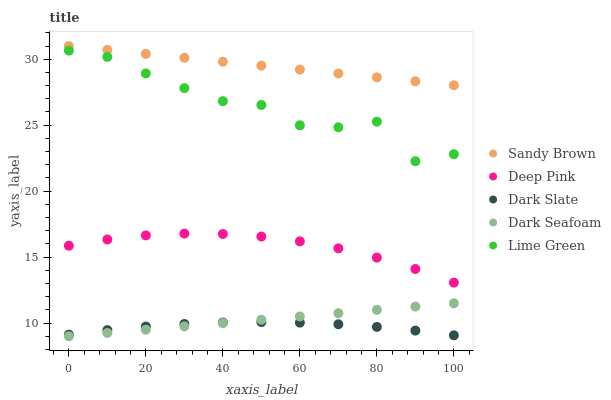Does Dark Slate have the minimum area under the curve?
Answer yes or no. Yes. Does Sandy Brown have the maximum area under the curve?
Answer yes or no. Yes. Does Dark Seafoam have the minimum area under the curve?
Answer yes or no. No. Does Dark Seafoam have the maximum area under the curve?
Answer yes or no. No. Is Sandy Brown the smoothest?
Answer yes or no. Yes. Is Lime Green the roughest?
Answer yes or no. Yes. Is Dark Seafoam the smoothest?
Answer yes or no. No. Is Dark Seafoam the roughest?
Answer yes or no. No. Does Dark Seafoam have the lowest value?
Answer yes or no. Yes. Does Deep Pink have the lowest value?
Answer yes or no. No. Does Sandy Brown have the highest value?
Answer yes or no. Yes. Does Dark Seafoam have the highest value?
Answer yes or no. No. Is Dark Seafoam less than Deep Pink?
Answer yes or no. Yes. Is Lime Green greater than Deep Pink?
Answer yes or no. Yes. Does Dark Slate intersect Dark Seafoam?
Answer yes or no. Yes. Is Dark Slate less than Dark Seafoam?
Answer yes or no. No. Is Dark Slate greater than Dark Seafoam?
Answer yes or no. No. Does Dark Seafoam intersect Deep Pink?
Answer yes or no. No. 